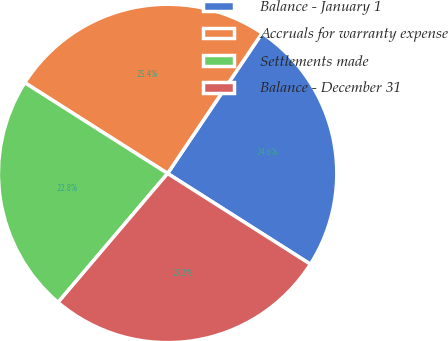<chart> <loc_0><loc_0><loc_500><loc_500><pie_chart><fcel>Balance - January 1<fcel>Accruals for warranty expense<fcel>Settlements made<fcel>Balance - December 31<nl><fcel>24.58%<fcel>25.42%<fcel>22.8%<fcel>27.2%<nl></chart> 